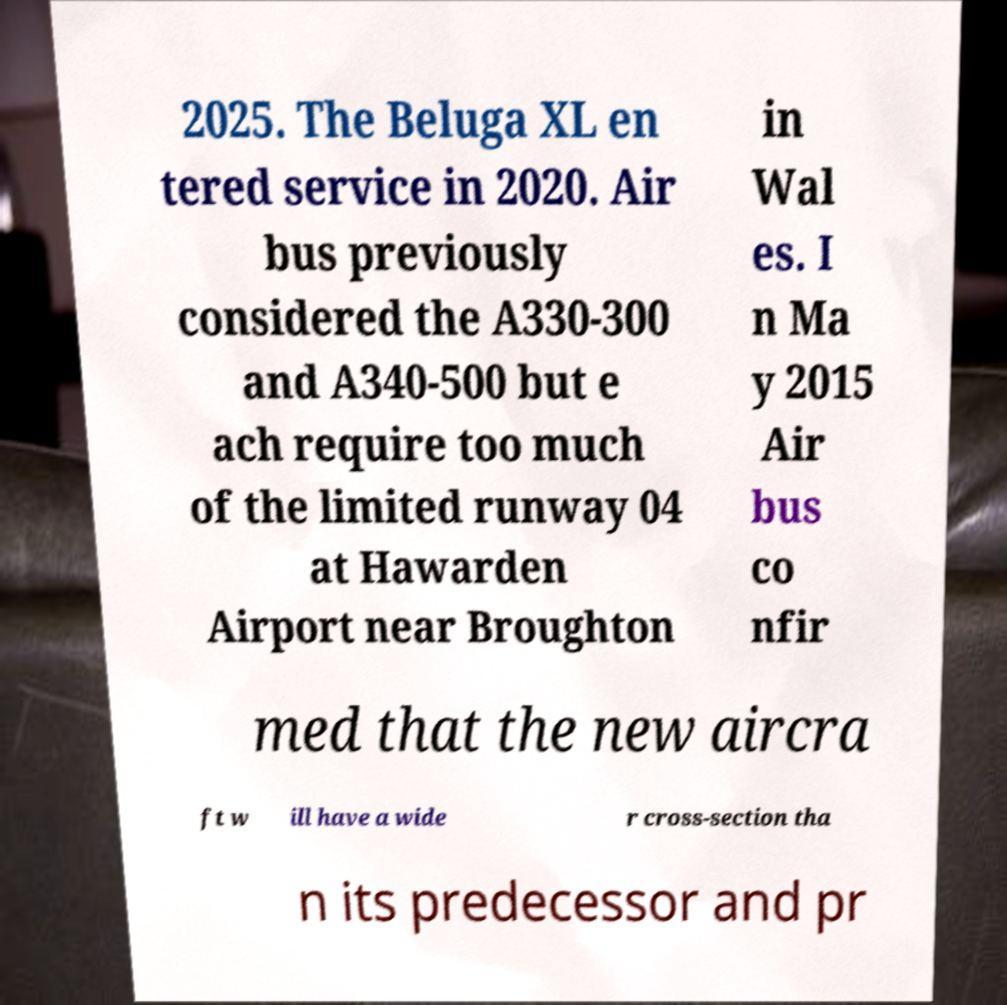I need the written content from this picture converted into text. Can you do that? 2025. The Beluga XL en tered service in 2020. Air bus previously considered the A330-300 and A340-500 but e ach require too much of the limited runway 04 at Hawarden Airport near Broughton in Wal es. I n Ma y 2015 Air bus co nfir med that the new aircra ft w ill have a wide r cross-section tha n its predecessor and pr 